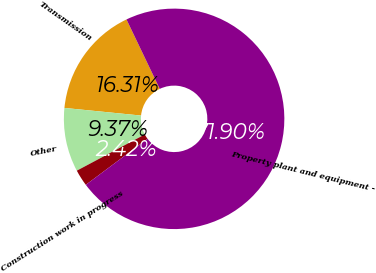Convert chart to OTSL. <chart><loc_0><loc_0><loc_500><loc_500><pie_chart><fcel>Transmission<fcel>Other<fcel>Construction work in progress<fcel>Property plant and equipment -<nl><fcel>16.31%<fcel>9.37%<fcel>2.42%<fcel>71.9%<nl></chart> 